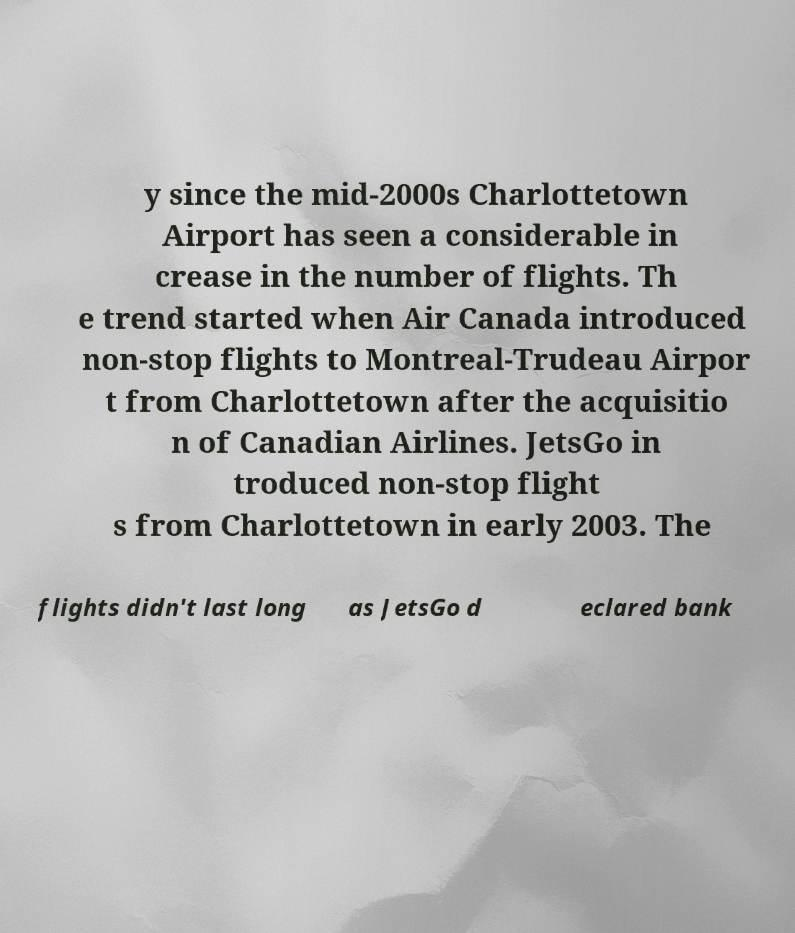There's text embedded in this image that I need extracted. Can you transcribe it verbatim? y since the mid-2000s Charlottetown Airport has seen a considerable in crease in the number of flights. Th e trend started when Air Canada introduced non-stop flights to Montreal-Trudeau Airpor t from Charlottetown after the acquisitio n of Canadian Airlines. JetsGo in troduced non-stop flight s from Charlottetown in early 2003. The flights didn't last long as JetsGo d eclared bank 